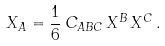Convert formula to latex. <formula><loc_0><loc_0><loc_500><loc_500>X _ { A } = \frac { 1 } { 6 } \, C _ { A B C } \, X ^ { B } \, X ^ { C } \, .</formula> 